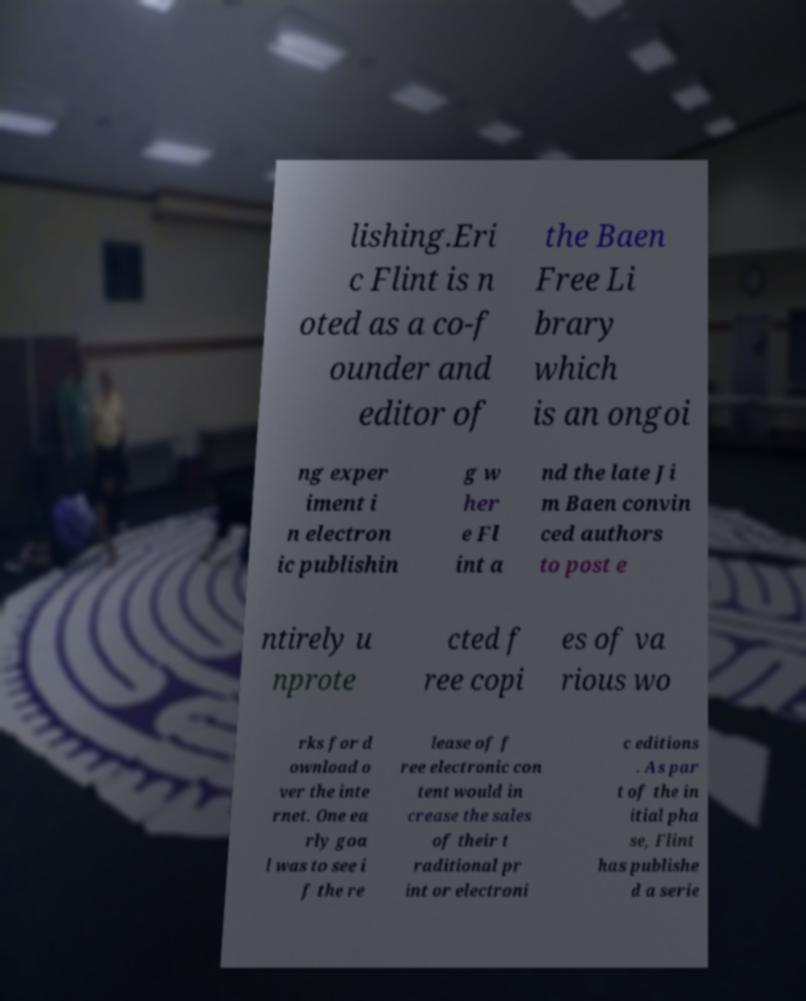For documentation purposes, I need the text within this image transcribed. Could you provide that? lishing.Eri c Flint is n oted as a co-f ounder and editor of the Baen Free Li brary which is an ongoi ng exper iment i n electron ic publishin g w her e Fl int a nd the late Ji m Baen convin ced authors to post e ntirely u nprote cted f ree copi es of va rious wo rks for d ownload o ver the inte rnet. One ea rly goa l was to see i f the re lease of f ree electronic con tent would in crease the sales of their t raditional pr int or electroni c editions . As par t of the in itial pha se, Flint has publishe d a serie 